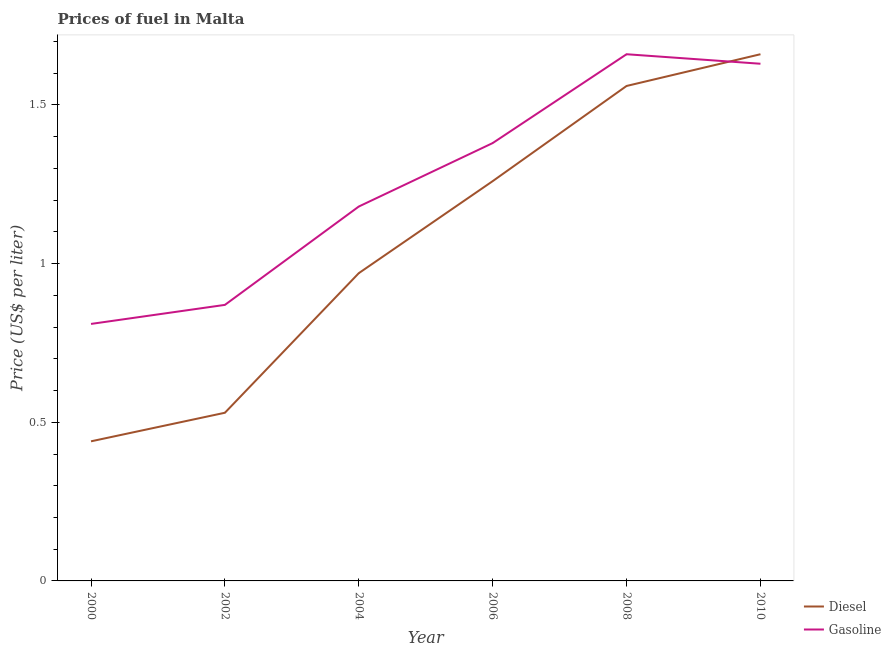Does the line corresponding to gasoline price intersect with the line corresponding to diesel price?
Give a very brief answer. Yes. Is the number of lines equal to the number of legend labels?
Provide a short and direct response. Yes. What is the diesel price in 2004?
Your answer should be very brief. 0.97. Across all years, what is the maximum gasoline price?
Provide a succinct answer. 1.66. Across all years, what is the minimum gasoline price?
Your answer should be very brief. 0.81. What is the total gasoline price in the graph?
Your response must be concise. 7.53. What is the difference between the gasoline price in 2000 and that in 2002?
Your response must be concise. -0.06. What is the difference between the gasoline price in 2010 and the diesel price in 2006?
Keep it short and to the point. 0.37. What is the average gasoline price per year?
Provide a succinct answer. 1.26. In the year 2004, what is the difference between the diesel price and gasoline price?
Provide a succinct answer. -0.21. In how many years, is the gasoline price greater than 1.1 US$ per litre?
Keep it short and to the point. 4. What is the ratio of the diesel price in 2008 to that in 2010?
Ensure brevity in your answer.  0.94. What is the difference between the highest and the second highest diesel price?
Provide a succinct answer. 0.1. What is the difference between the highest and the lowest diesel price?
Provide a short and direct response. 1.22. What is the difference between two consecutive major ticks on the Y-axis?
Ensure brevity in your answer.  0.5. Where does the legend appear in the graph?
Offer a very short reply. Bottom right. What is the title of the graph?
Provide a succinct answer. Prices of fuel in Malta. What is the label or title of the Y-axis?
Give a very brief answer. Price (US$ per liter). What is the Price (US$ per liter) in Diesel in 2000?
Offer a terse response. 0.44. What is the Price (US$ per liter) in Gasoline in 2000?
Your response must be concise. 0.81. What is the Price (US$ per liter) of Diesel in 2002?
Your answer should be very brief. 0.53. What is the Price (US$ per liter) in Gasoline in 2002?
Keep it short and to the point. 0.87. What is the Price (US$ per liter) of Gasoline in 2004?
Make the answer very short. 1.18. What is the Price (US$ per liter) of Diesel in 2006?
Make the answer very short. 1.26. What is the Price (US$ per liter) in Gasoline in 2006?
Keep it short and to the point. 1.38. What is the Price (US$ per liter) in Diesel in 2008?
Provide a succinct answer. 1.56. What is the Price (US$ per liter) in Gasoline in 2008?
Give a very brief answer. 1.66. What is the Price (US$ per liter) of Diesel in 2010?
Your answer should be very brief. 1.66. What is the Price (US$ per liter) in Gasoline in 2010?
Provide a succinct answer. 1.63. Across all years, what is the maximum Price (US$ per liter) in Diesel?
Keep it short and to the point. 1.66. Across all years, what is the maximum Price (US$ per liter) of Gasoline?
Provide a short and direct response. 1.66. Across all years, what is the minimum Price (US$ per liter) of Diesel?
Make the answer very short. 0.44. Across all years, what is the minimum Price (US$ per liter) of Gasoline?
Offer a very short reply. 0.81. What is the total Price (US$ per liter) of Diesel in the graph?
Offer a very short reply. 6.42. What is the total Price (US$ per liter) of Gasoline in the graph?
Keep it short and to the point. 7.53. What is the difference between the Price (US$ per liter) in Diesel in 2000 and that in 2002?
Provide a short and direct response. -0.09. What is the difference between the Price (US$ per liter) of Gasoline in 2000 and that in 2002?
Ensure brevity in your answer.  -0.06. What is the difference between the Price (US$ per liter) in Diesel in 2000 and that in 2004?
Your answer should be compact. -0.53. What is the difference between the Price (US$ per liter) of Gasoline in 2000 and that in 2004?
Your answer should be very brief. -0.37. What is the difference between the Price (US$ per liter) of Diesel in 2000 and that in 2006?
Your answer should be compact. -0.82. What is the difference between the Price (US$ per liter) in Gasoline in 2000 and that in 2006?
Your response must be concise. -0.57. What is the difference between the Price (US$ per liter) of Diesel in 2000 and that in 2008?
Give a very brief answer. -1.12. What is the difference between the Price (US$ per liter) in Gasoline in 2000 and that in 2008?
Your answer should be compact. -0.85. What is the difference between the Price (US$ per liter) in Diesel in 2000 and that in 2010?
Offer a very short reply. -1.22. What is the difference between the Price (US$ per liter) in Gasoline in 2000 and that in 2010?
Give a very brief answer. -0.82. What is the difference between the Price (US$ per liter) of Diesel in 2002 and that in 2004?
Keep it short and to the point. -0.44. What is the difference between the Price (US$ per liter) of Gasoline in 2002 and that in 2004?
Provide a short and direct response. -0.31. What is the difference between the Price (US$ per liter) in Diesel in 2002 and that in 2006?
Provide a short and direct response. -0.73. What is the difference between the Price (US$ per liter) of Gasoline in 2002 and that in 2006?
Provide a short and direct response. -0.51. What is the difference between the Price (US$ per liter) of Diesel in 2002 and that in 2008?
Your answer should be very brief. -1.03. What is the difference between the Price (US$ per liter) in Gasoline in 2002 and that in 2008?
Provide a short and direct response. -0.79. What is the difference between the Price (US$ per liter) in Diesel in 2002 and that in 2010?
Make the answer very short. -1.13. What is the difference between the Price (US$ per liter) of Gasoline in 2002 and that in 2010?
Give a very brief answer. -0.76. What is the difference between the Price (US$ per liter) of Diesel in 2004 and that in 2006?
Your answer should be very brief. -0.29. What is the difference between the Price (US$ per liter) of Diesel in 2004 and that in 2008?
Ensure brevity in your answer.  -0.59. What is the difference between the Price (US$ per liter) in Gasoline in 2004 and that in 2008?
Ensure brevity in your answer.  -0.48. What is the difference between the Price (US$ per liter) in Diesel in 2004 and that in 2010?
Your response must be concise. -0.69. What is the difference between the Price (US$ per liter) in Gasoline in 2004 and that in 2010?
Your answer should be very brief. -0.45. What is the difference between the Price (US$ per liter) in Gasoline in 2006 and that in 2008?
Offer a terse response. -0.28. What is the difference between the Price (US$ per liter) in Diesel in 2006 and that in 2010?
Your answer should be compact. -0.4. What is the difference between the Price (US$ per liter) in Gasoline in 2006 and that in 2010?
Make the answer very short. -0.25. What is the difference between the Price (US$ per liter) of Diesel in 2008 and that in 2010?
Your answer should be compact. -0.1. What is the difference between the Price (US$ per liter) in Gasoline in 2008 and that in 2010?
Offer a terse response. 0.03. What is the difference between the Price (US$ per liter) in Diesel in 2000 and the Price (US$ per liter) in Gasoline in 2002?
Provide a short and direct response. -0.43. What is the difference between the Price (US$ per liter) of Diesel in 2000 and the Price (US$ per liter) of Gasoline in 2004?
Provide a short and direct response. -0.74. What is the difference between the Price (US$ per liter) of Diesel in 2000 and the Price (US$ per liter) of Gasoline in 2006?
Your answer should be compact. -0.94. What is the difference between the Price (US$ per liter) in Diesel in 2000 and the Price (US$ per liter) in Gasoline in 2008?
Give a very brief answer. -1.22. What is the difference between the Price (US$ per liter) of Diesel in 2000 and the Price (US$ per liter) of Gasoline in 2010?
Make the answer very short. -1.19. What is the difference between the Price (US$ per liter) of Diesel in 2002 and the Price (US$ per liter) of Gasoline in 2004?
Your answer should be very brief. -0.65. What is the difference between the Price (US$ per liter) in Diesel in 2002 and the Price (US$ per liter) in Gasoline in 2006?
Make the answer very short. -0.85. What is the difference between the Price (US$ per liter) in Diesel in 2002 and the Price (US$ per liter) in Gasoline in 2008?
Ensure brevity in your answer.  -1.13. What is the difference between the Price (US$ per liter) of Diesel in 2004 and the Price (US$ per liter) of Gasoline in 2006?
Keep it short and to the point. -0.41. What is the difference between the Price (US$ per liter) of Diesel in 2004 and the Price (US$ per liter) of Gasoline in 2008?
Provide a succinct answer. -0.69. What is the difference between the Price (US$ per liter) in Diesel in 2004 and the Price (US$ per liter) in Gasoline in 2010?
Your answer should be compact. -0.66. What is the difference between the Price (US$ per liter) of Diesel in 2006 and the Price (US$ per liter) of Gasoline in 2010?
Make the answer very short. -0.37. What is the difference between the Price (US$ per liter) in Diesel in 2008 and the Price (US$ per liter) in Gasoline in 2010?
Offer a terse response. -0.07. What is the average Price (US$ per liter) of Diesel per year?
Your answer should be compact. 1.07. What is the average Price (US$ per liter) of Gasoline per year?
Your answer should be compact. 1.25. In the year 2000, what is the difference between the Price (US$ per liter) of Diesel and Price (US$ per liter) of Gasoline?
Make the answer very short. -0.37. In the year 2002, what is the difference between the Price (US$ per liter) in Diesel and Price (US$ per liter) in Gasoline?
Your response must be concise. -0.34. In the year 2004, what is the difference between the Price (US$ per liter) in Diesel and Price (US$ per liter) in Gasoline?
Ensure brevity in your answer.  -0.21. In the year 2006, what is the difference between the Price (US$ per liter) in Diesel and Price (US$ per liter) in Gasoline?
Your answer should be very brief. -0.12. In the year 2008, what is the difference between the Price (US$ per liter) in Diesel and Price (US$ per liter) in Gasoline?
Keep it short and to the point. -0.1. In the year 2010, what is the difference between the Price (US$ per liter) in Diesel and Price (US$ per liter) in Gasoline?
Your answer should be very brief. 0.03. What is the ratio of the Price (US$ per liter) of Diesel in 2000 to that in 2002?
Your response must be concise. 0.83. What is the ratio of the Price (US$ per liter) in Diesel in 2000 to that in 2004?
Keep it short and to the point. 0.45. What is the ratio of the Price (US$ per liter) of Gasoline in 2000 to that in 2004?
Offer a terse response. 0.69. What is the ratio of the Price (US$ per liter) in Diesel in 2000 to that in 2006?
Your answer should be compact. 0.35. What is the ratio of the Price (US$ per liter) of Gasoline in 2000 to that in 2006?
Provide a succinct answer. 0.59. What is the ratio of the Price (US$ per liter) of Diesel in 2000 to that in 2008?
Provide a short and direct response. 0.28. What is the ratio of the Price (US$ per liter) in Gasoline in 2000 to that in 2008?
Ensure brevity in your answer.  0.49. What is the ratio of the Price (US$ per liter) in Diesel in 2000 to that in 2010?
Offer a terse response. 0.27. What is the ratio of the Price (US$ per liter) of Gasoline in 2000 to that in 2010?
Give a very brief answer. 0.5. What is the ratio of the Price (US$ per liter) in Diesel in 2002 to that in 2004?
Your response must be concise. 0.55. What is the ratio of the Price (US$ per liter) of Gasoline in 2002 to that in 2004?
Your answer should be compact. 0.74. What is the ratio of the Price (US$ per liter) in Diesel in 2002 to that in 2006?
Your answer should be compact. 0.42. What is the ratio of the Price (US$ per liter) in Gasoline in 2002 to that in 2006?
Your answer should be very brief. 0.63. What is the ratio of the Price (US$ per liter) of Diesel in 2002 to that in 2008?
Ensure brevity in your answer.  0.34. What is the ratio of the Price (US$ per liter) in Gasoline in 2002 to that in 2008?
Make the answer very short. 0.52. What is the ratio of the Price (US$ per liter) of Diesel in 2002 to that in 2010?
Provide a short and direct response. 0.32. What is the ratio of the Price (US$ per liter) of Gasoline in 2002 to that in 2010?
Your answer should be very brief. 0.53. What is the ratio of the Price (US$ per liter) in Diesel in 2004 to that in 2006?
Your answer should be compact. 0.77. What is the ratio of the Price (US$ per liter) in Gasoline in 2004 to that in 2006?
Offer a very short reply. 0.86. What is the ratio of the Price (US$ per liter) in Diesel in 2004 to that in 2008?
Your response must be concise. 0.62. What is the ratio of the Price (US$ per liter) in Gasoline in 2004 to that in 2008?
Give a very brief answer. 0.71. What is the ratio of the Price (US$ per liter) in Diesel in 2004 to that in 2010?
Give a very brief answer. 0.58. What is the ratio of the Price (US$ per liter) of Gasoline in 2004 to that in 2010?
Your answer should be very brief. 0.72. What is the ratio of the Price (US$ per liter) of Diesel in 2006 to that in 2008?
Your answer should be very brief. 0.81. What is the ratio of the Price (US$ per liter) in Gasoline in 2006 to that in 2008?
Your answer should be compact. 0.83. What is the ratio of the Price (US$ per liter) in Diesel in 2006 to that in 2010?
Offer a very short reply. 0.76. What is the ratio of the Price (US$ per liter) of Gasoline in 2006 to that in 2010?
Provide a succinct answer. 0.85. What is the ratio of the Price (US$ per liter) in Diesel in 2008 to that in 2010?
Make the answer very short. 0.94. What is the ratio of the Price (US$ per liter) of Gasoline in 2008 to that in 2010?
Your answer should be very brief. 1.02. What is the difference between the highest and the second highest Price (US$ per liter) in Gasoline?
Make the answer very short. 0.03. What is the difference between the highest and the lowest Price (US$ per liter) of Diesel?
Your answer should be compact. 1.22. What is the difference between the highest and the lowest Price (US$ per liter) of Gasoline?
Give a very brief answer. 0.85. 